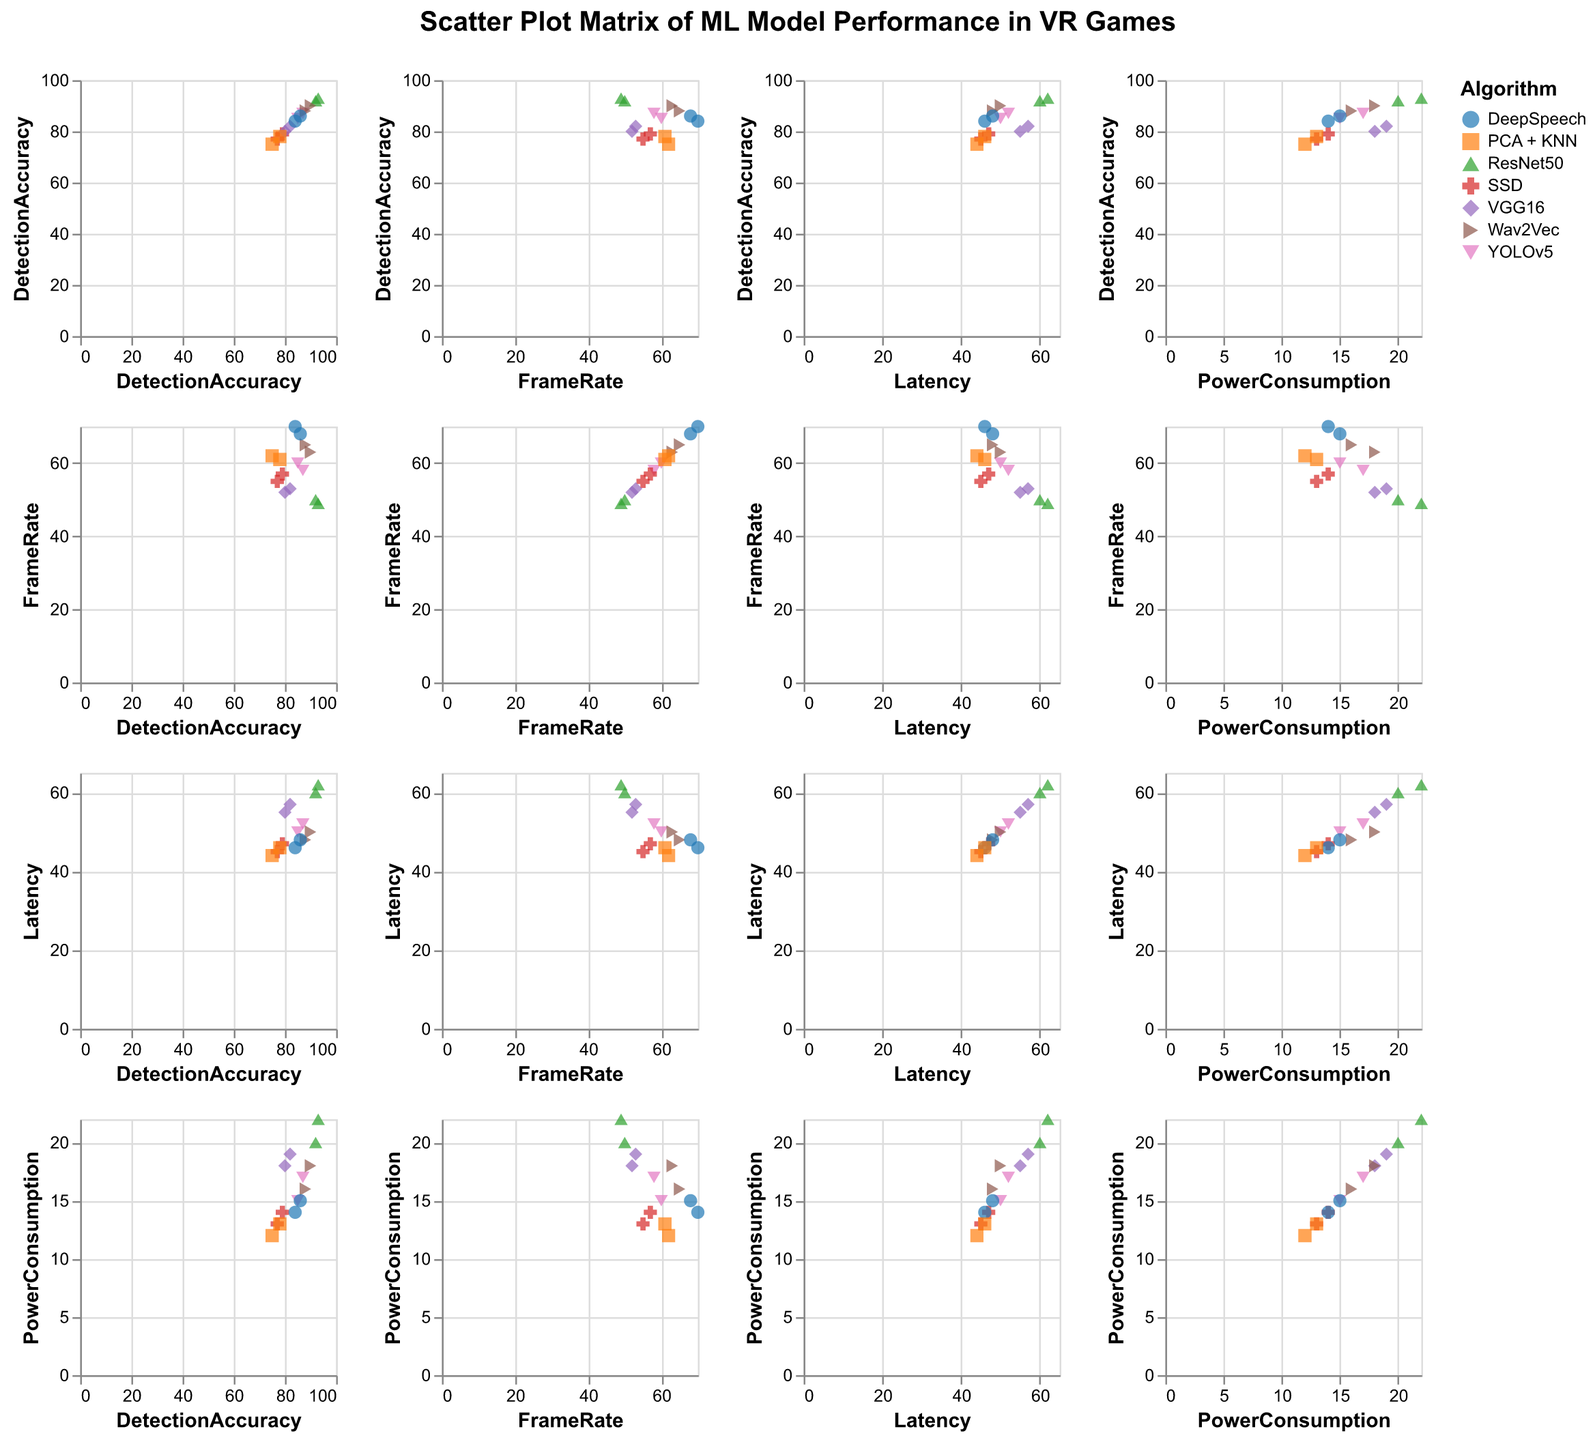How many different algorithms are plotted in the figure? Identify the number of unique algorithms listed in the legend and marked on the axes. In total, there are 7 unique algorithms: YOLOv5, SSD, ResNet50, VGG16, Wav2Vec, DeepSpeech, and PCA + KNN.
Answer: 7 Which algorithm has the highest detection accuracy? Look at the scatter plot points on the x-axis labeled "Detection Accuracy" and find the one with the highest value. ResNet50 boasts the highest detection accuracy, reaching up to 93.
Answer: ResNet50 Between which pair of metrics from the figure do we see VGG16 exhibiting the highest latency? Find the plotted points for VGG16 and identify the pair of metrics where its latency value peaks. For VGG16, the highest latency values are observed in the Latency vs. Detection Accuracy plots.
Answer: Detection Accuracy and Latency What is the power consumption range for DeepSpeech? Look at the scatter plot points for DeepSpeech under "PowerConsumption" in the matrix and identify the minimum and maximum values. DeepSpeech has power consumption values of 14 and 15.
Answer: 14-15 Comparing Wav2Vec and DeepSpeech, which has a higher frame rate and by how much? Locate the frame rate values for both algorithms in the scatter plot. Wav2Vec exhibits frame rates of 63 and 65, whereas DeepSpeech exhibits frame rates of 68 and 70. The difference for the maximum frame rate is 70 - 65 = 5.
Answer: DeepSpeech by 5 Which algorithm demonstrates the lowest latency across the performance metrics plotted? Search for the lowest latency values across all plotted metrics and algorithms in the matrix. PCA + KNN demonstrates the lowest latency, reaching as low as 44.
Answer: PCA + KNN Is there a correlation between detection accuracy and power consumption for YOLOv5? Examine the scatter plot points for YOLOv5 in the Detection Accuracy vs. PowerConsumption plots to determine if there's a visible pattern or relationship. The plotted points for YOLOv5 suggest a possible positive correlation between detection accuracy and power consumption.
Answer: Yes, positive correlation How does ResNet50's frame rate compare to SSD's? Focus on the frame rate scatter plots for both ResNet50 and SSD to see if one consistently shows higher or lower values. ResNet50 has lower frame rates, between 49 and 50, while SSD ranges between 55 and 57.
Answer: ResNet50 has a lower frame rate Which algorithm shows a higher variation in detection accuracy, YOLOv5 or VGG16? Compare the difference between the maximum and minimum detection accuracy values for both algorithms. YOLOv5 varies from 85 to 87, and VGG16 varies from 80 to 82. Thus, YOLOv5 has a higher variation (87 - 85 = 2 compared to 82 - 80 = 2).
Answer: Both have the same variation 